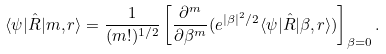Convert formula to latex. <formula><loc_0><loc_0><loc_500><loc_500>\langle \psi | \hat { R } | m , r \rangle = \frac { 1 } { ( m ! ) ^ { 1 / 2 } } \left [ \frac { \partial ^ { m } } { \partial \beta ^ { m } } ( e ^ { | \beta | ^ { 2 } / 2 } \langle \psi | \hat { R } | \beta , r \rangle ) \right ] _ { \beta = 0 } .</formula> 